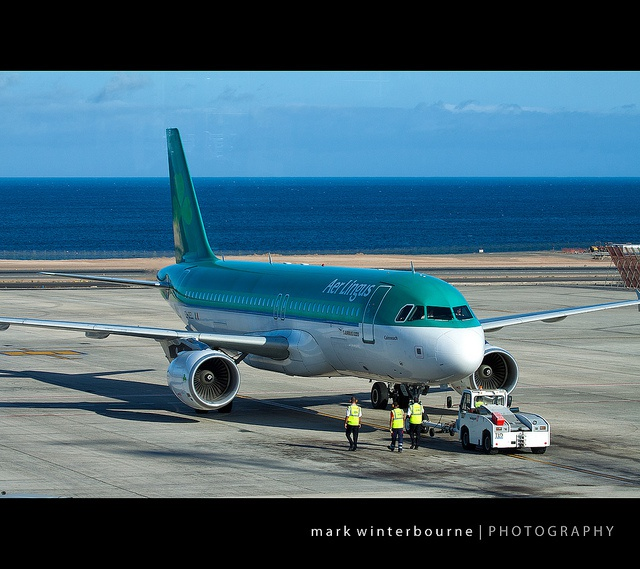Describe the objects in this image and their specific colors. I can see airplane in black, teal, and gray tones, truck in black, white, gray, and darkgray tones, people in black, yellow, gray, and navy tones, people in black, yellow, khaki, and gray tones, and people in black, yellow, khaki, and white tones in this image. 